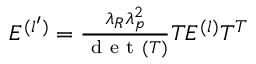Convert formula to latex. <formula><loc_0><loc_0><loc_500><loc_500>\begin{array} { r } { E ^ { ( l ^ { \prime } ) } = \frac { \lambda _ { R } \lambda _ { p } ^ { 2 } } { d e t ( T ) } T E ^ { ( l ) } T ^ { T } } \end{array}</formula> 